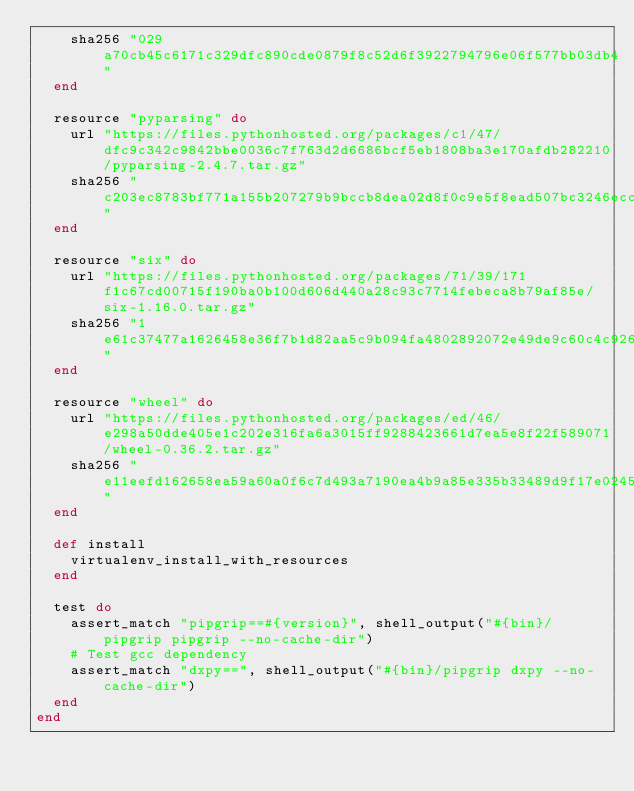<code> <loc_0><loc_0><loc_500><loc_500><_Ruby_>    sha256 "029a70cb45c6171c329dfc890cde0879f8c52d6f3922794796e06f577bb03db4"
  end

  resource "pyparsing" do
    url "https://files.pythonhosted.org/packages/c1/47/dfc9c342c9842bbe0036c7f763d2d6686bcf5eb1808ba3e170afdb282210/pyparsing-2.4.7.tar.gz"
    sha256 "c203ec8783bf771a155b207279b9bccb8dea02d8f0c9e5f8ead507bc3246ecc1"
  end

  resource "six" do
    url "https://files.pythonhosted.org/packages/71/39/171f1c67cd00715f190ba0b100d606d440a28c93c7714febeca8b79af85e/six-1.16.0.tar.gz"
    sha256 "1e61c37477a1626458e36f7b1d82aa5c9b094fa4802892072e49de9c60c4c926"
  end

  resource "wheel" do
    url "https://files.pythonhosted.org/packages/ed/46/e298a50dde405e1c202e316fa6a3015ff9288423661d7ea5e8f22f589071/wheel-0.36.2.tar.gz"
    sha256 "e11eefd162658ea59a60a0f6c7d493a7190ea4b9a85e335b33489d9f17e0245e"
  end

  def install
    virtualenv_install_with_resources
  end

  test do
    assert_match "pipgrip==#{version}", shell_output("#{bin}/pipgrip pipgrip --no-cache-dir")
    # Test gcc dependency
    assert_match "dxpy==", shell_output("#{bin}/pipgrip dxpy --no-cache-dir")
  end
end
</code> 